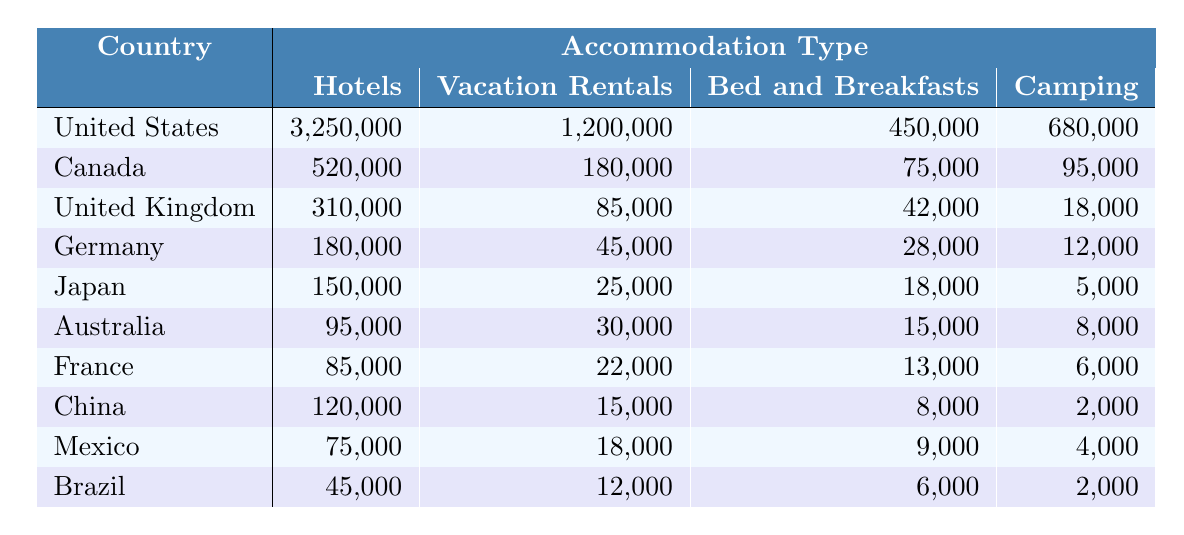What is the total number of tourists from the United States? The number of tourists from the United States can be found by looking at the "Hotels," "Vacation Rentals," "Bed and Breakfasts," and "Camping" categories. Adding these values gives: 3,250,000 + 1,200,000 + 450,000 + 680,000 = 5,580,000.
Answer: 5,580,000 Which accommodation type is most preferred by tourists from Canada? In the Canada row, the values under each accommodation type show that "Hotels" has the highest number at 520,000. Therefore, the most preferred accommodation type for tourists from Canada is "Hotels."
Answer: Hotels What is the total number of tourists from Japan and Australia combined? To find this, I will add the total tourists from Japan (Hotels + Vacation Rentals + Bed and Breakfasts + Camping = 150,000 + 25,000 + 18,000 + 5,000 = 198,000) and Australia (Hotels + Vacation Rentals + Bed and Breakfasts + Camping = 95,000 + 30,000 + 15,000 + 8,000 = 148,000). The combined total is 198,000 + 148,000 = 346,000.
Answer: 346,000 How many tourists from the United Kingdom chose "Vacation Rentals"? Looking at the "Vacation Rentals" column in the United Kingdom row, the value is 85,000, so this is the number of tourists who chose "Vacation Rentals."
Answer: 85,000 Is the number of tourists staying in "Bed and Breakfasts" higher for Germany than for Canada? For Germany, the number is 28,000, and for Canada, it is 75,000. Since 28,000 is less than 75,000, the statement is false.
Answer: No What is the average number of tourists staying in "Camping" accommodation across all listed countries? To find the average, I first add the "Camping" values from all countries: 680,000 + 95,000 + 18,000 + 12,000 + 5,000 + 8,000 + 6,000 + 2,000 + 4,000 + 2,000 = 830,000. There are 10 countries, so the average is 830,000 / 10 = 83,000.
Answer: 83,000 Which country has the least number of tourists staying in "Vacation Rentals"? By examining the "Vacation Rentals" column, Brazil has the least number with 12,000.
Answer: Brazil What is the difference in the number of tourists between the highest and lowest preferred accommodation type for Germany? For Germany, "Hotels" has 180,000 tourists and "Camping" has 12,000. The difference is 180,000 - 12,000 = 168,000.
Answer: 168,000 Which accommodation type received the highest number of tourists from the United States? The highest number of tourists from the United States is found in the "Hotels" category with 3,250,000.
Answer: Hotels If you combine the tourists from Mexico and Brazil, which accommodation type has the highest total? First, for Mexico, "Hotels" has 75,000 and for Brazil, it has 45,000. Adding these gives 75,000 + 45,000 = 120,000. Now for "Vacation Rentals," Mexico has 18,000 and Brazil has 12,000, totaling 30,000. For "Bed and Breakfasts," Mexico has 9,000 and Brazil has 6,000, totaling 15,000. Lastly, for "Camping," Mexico has 4,000 and Brazil has 2,000, totaling 6,000. The highest total is for "Hotels" at 120,000.
Answer: Hotels 